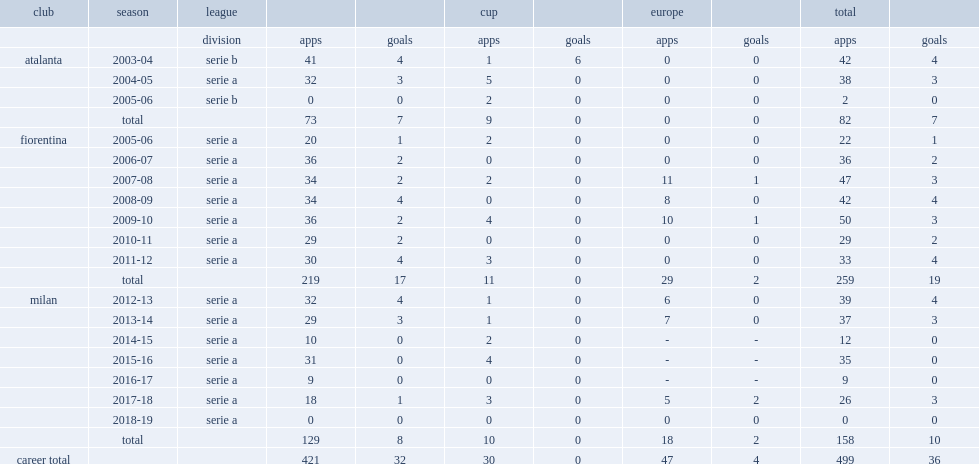Which club did riccardo montolivo appear in the 2004-05 league serie a? Atalanta. 